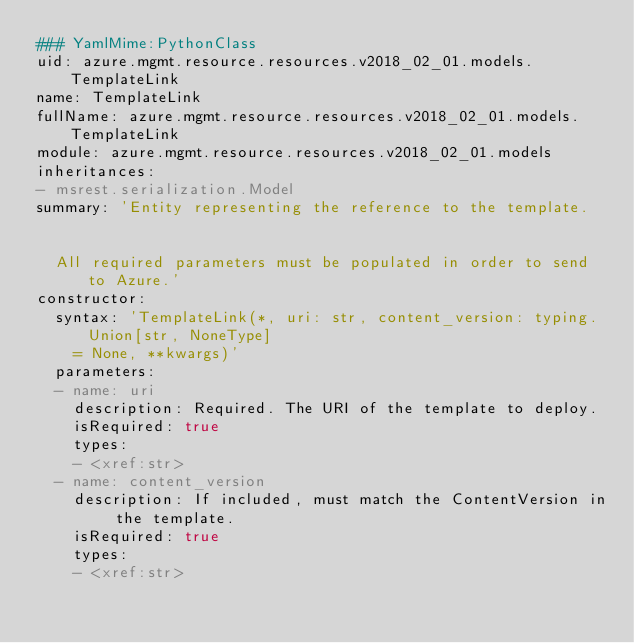<code> <loc_0><loc_0><loc_500><loc_500><_YAML_>### YamlMime:PythonClass
uid: azure.mgmt.resource.resources.v2018_02_01.models.TemplateLink
name: TemplateLink
fullName: azure.mgmt.resource.resources.v2018_02_01.models.TemplateLink
module: azure.mgmt.resource.resources.v2018_02_01.models
inheritances:
- msrest.serialization.Model
summary: 'Entity representing the reference to the template.


  All required parameters must be populated in order to send to Azure.'
constructor:
  syntax: 'TemplateLink(*, uri: str, content_version: typing.Union[str, NoneType]
    = None, **kwargs)'
  parameters:
  - name: uri
    description: Required. The URI of the template to deploy.
    isRequired: true
    types:
    - <xref:str>
  - name: content_version
    description: If included, must match the ContentVersion in the template.
    isRequired: true
    types:
    - <xref:str>
</code> 